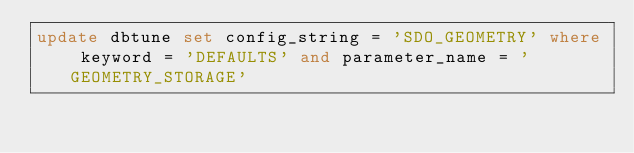Convert code to text. <code><loc_0><loc_0><loc_500><loc_500><_SQL_>update dbtune set config_string = 'SDO_GEOMETRY' where keyword = 'DEFAULTS' and parameter_name = 'GEOMETRY_STORAGE'</code> 